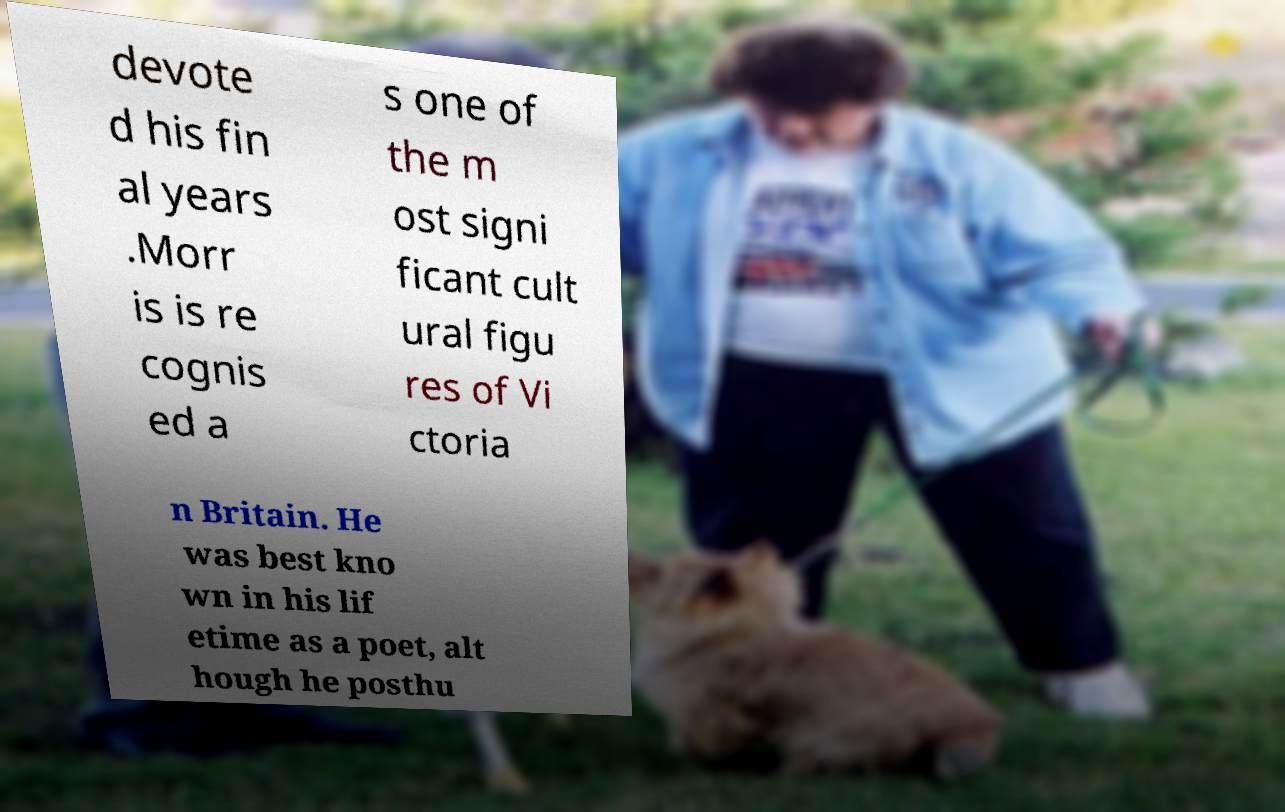Can you accurately transcribe the text from the provided image for me? devote d his fin al years .Morr is is re cognis ed a s one of the m ost signi ficant cult ural figu res of Vi ctoria n Britain. He was best kno wn in his lif etime as a poet, alt hough he posthu 